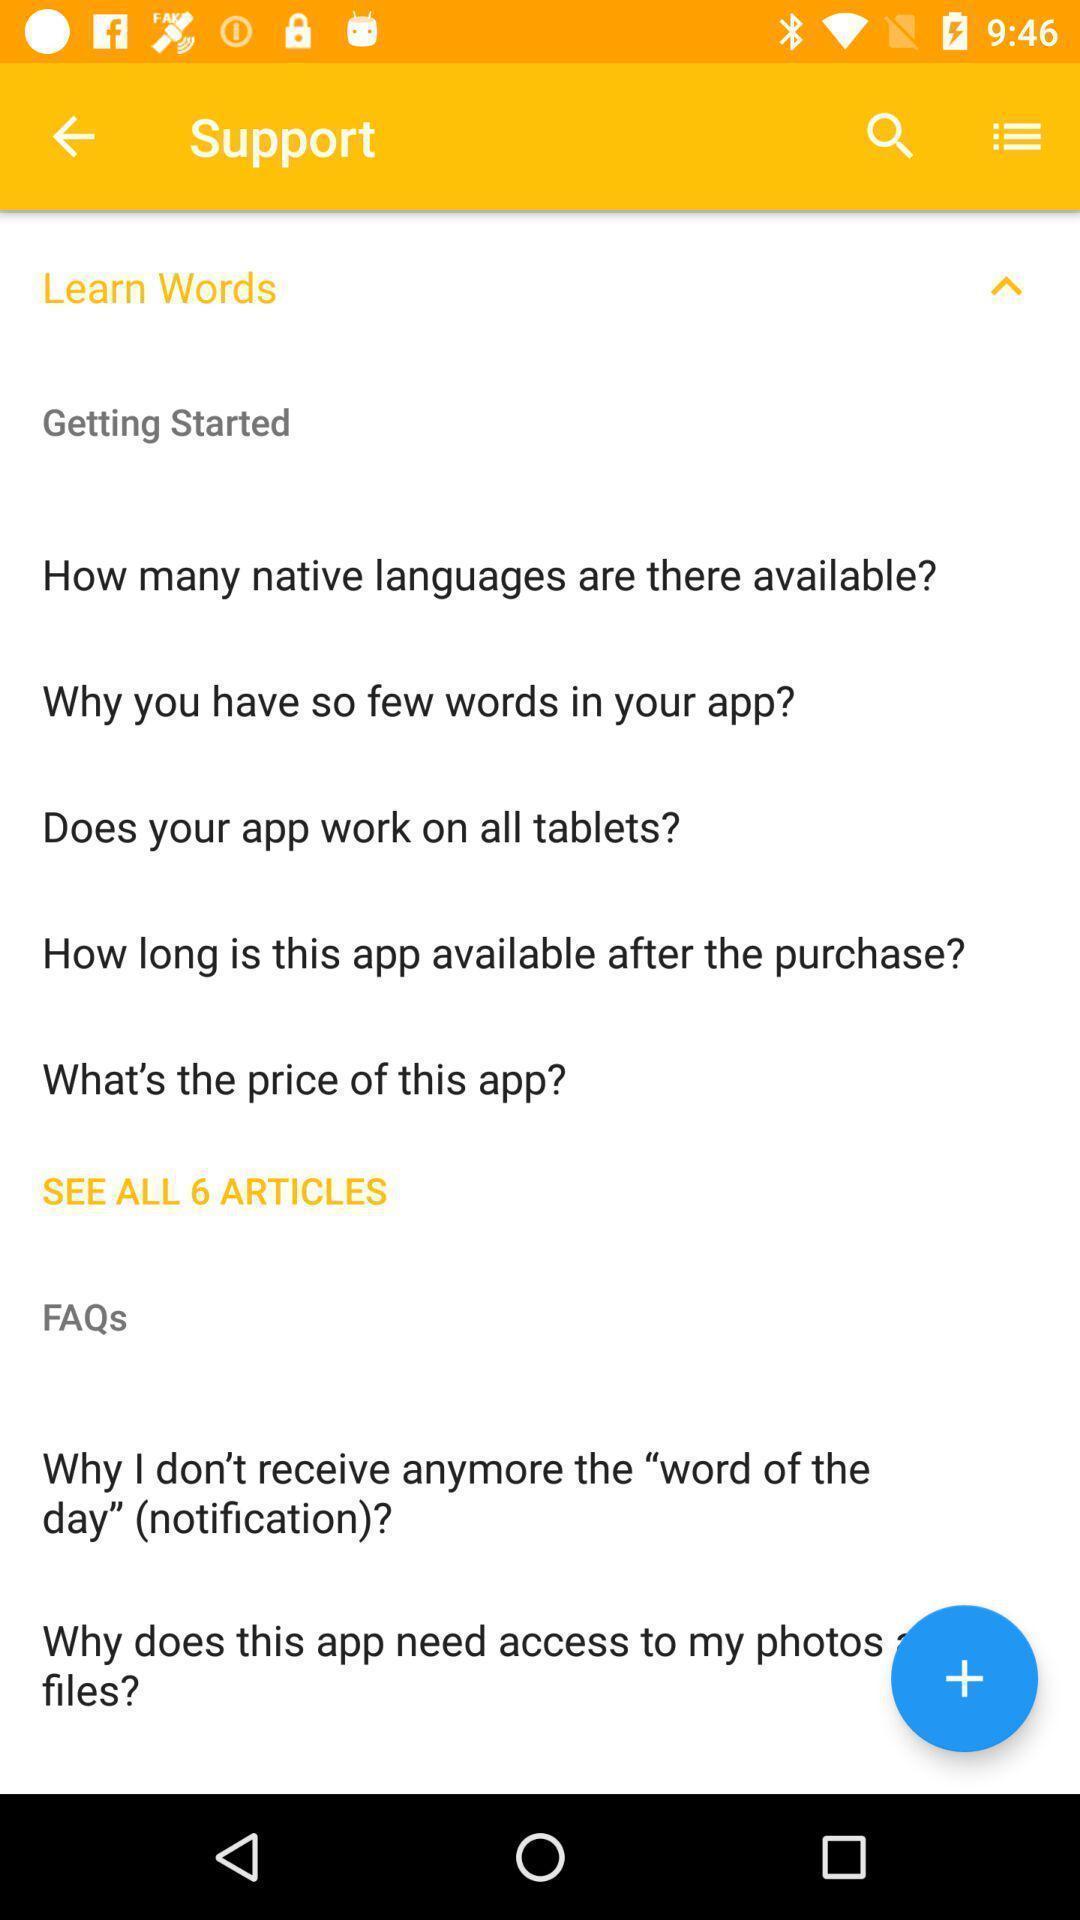Explain the elements present in this screenshot. Page displaying various information. 